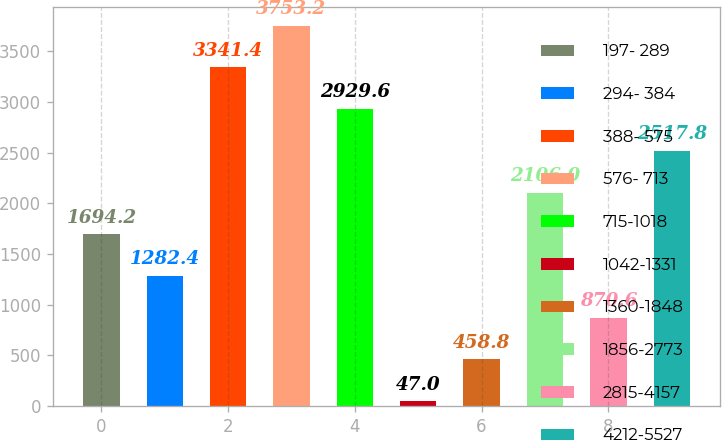Convert chart to OTSL. <chart><loc_0><loc_0><loc_500><loc_500><bar_chart><fcel>197- 289<fcel>294- 384<fcel>388- 575<fcel>576- 713<fcel>715-1018<fcel>1042-1331<fcel>1360-1848<fcel>1856-2773<fcel>2815-4157<fcel>4212-5527<nl><fcel>1694.2<fcel>1282.4<fcel>3341.4<fcel>3753.2<fcel>2929.6<fcel>47<fcel>458.8<fcel>2106<fcel>870.6<fcel>2517.8<nl></chart> 